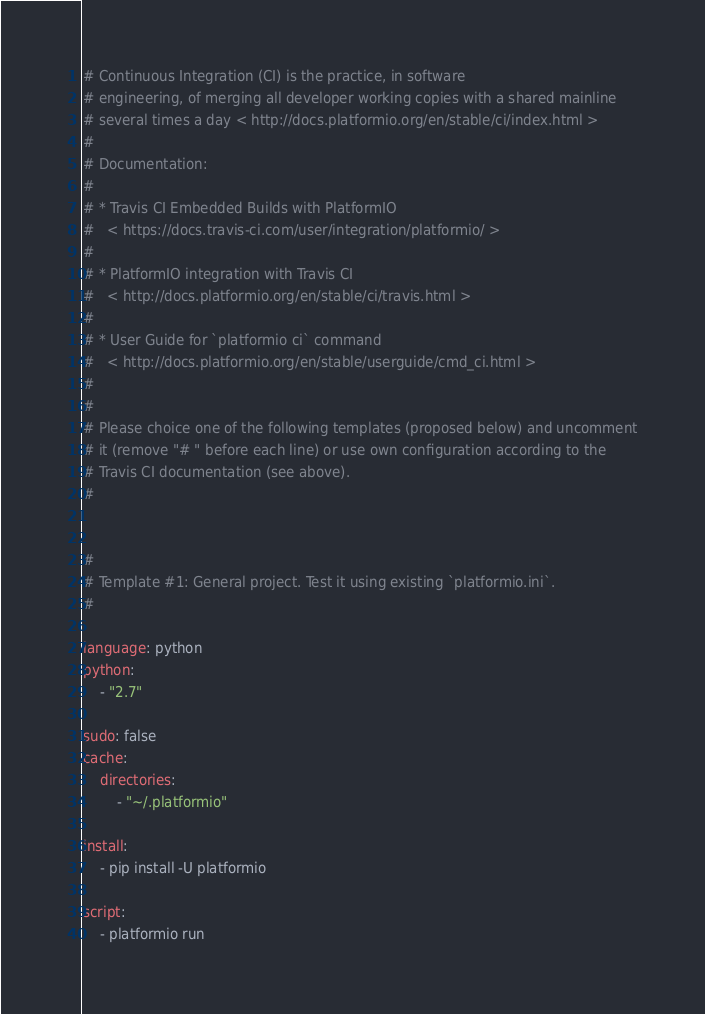Convert code to text. <code><loc_0><loc_0><loc_500><loc_500><_YAML_># Continuous Integration (CI) is the practice, in software
# engineering, of merging all developer working copies with a shared mainline
# several times a day < http://docs.platformio.org/en/stable/ci/index.html >
#
# Documentation:
#
# * Travis CI Embedded Builds with PlatformIO
#   < https://docs.travis-ci.com/user/integration/platformio/ >
#
# * PlatformIO integration with Travis CI
#   < http://docs.platformio.org/en/stable/ci/travis.html >
#
# * User Guide for `platformio ci` command
#   < http://docs.platformio.org/en/stable/userguide/cmd_ci.html >
#
#
# Please choice one of the following templates (proposed below) and uncomment
# it (remove "# " before each line) or use own configuration according to the
# Travis CI documentation (see above).
#


#
# Template #1: General project. Test it using existing `platformio.ini`.
#

language: python
python:
    - "2.7"

sudo: false
cache:
    directories:
        - "~/.platformio"

install:
    - pip install -U platformio

script:
    - platformio run
</code> 